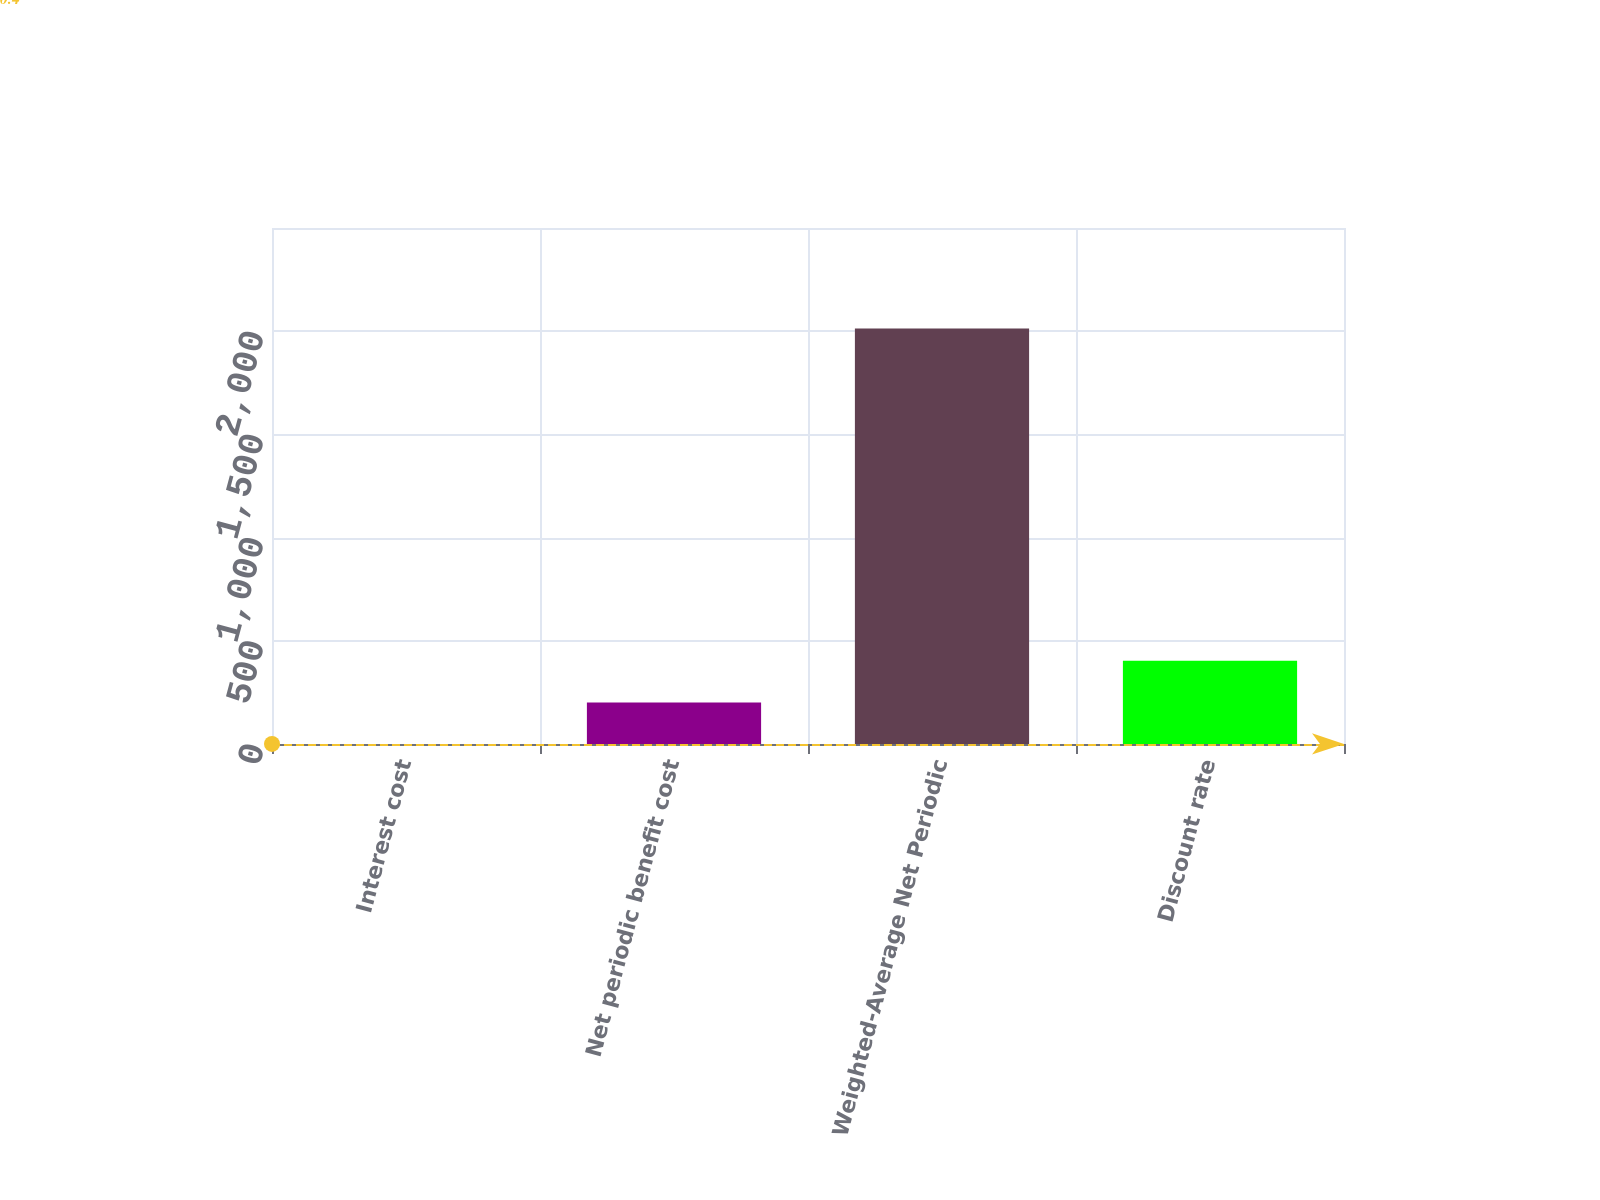Convert chart. <chart><loc_0><loc_0><loc_500><loc_500><bar_chart><fcel>Interest cost<fcel>Net periodic benefit cost<fcel>Weighted-Average Net Periodic<fcel>Discount rate<nl><fcel>0.4<fcel>201.66<fcel>2013<fcel>402.92<nl></chart> 